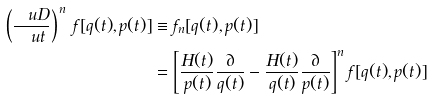Convert formula to latex. <formula><loc_0><loc_0><loc_500><loc_500>\left ( \frac { \ u D } { \ u t } \right ) ^ { \, n } \, f [ q ( t ) , p ( t ) ] & \equiv f _ { n } [ q ( t ) , p ( t ) ] \\ & = \left [ \frac { H ( t ) } { p ( t ) } \frac { \partial } { q ( t ) } - \frac { H ( t ) } { q ( t ) } \frac { \partial } { p ( t ) } \right ] ^ { n } f [ q ( t ) , p ( t ) ]</formula> 